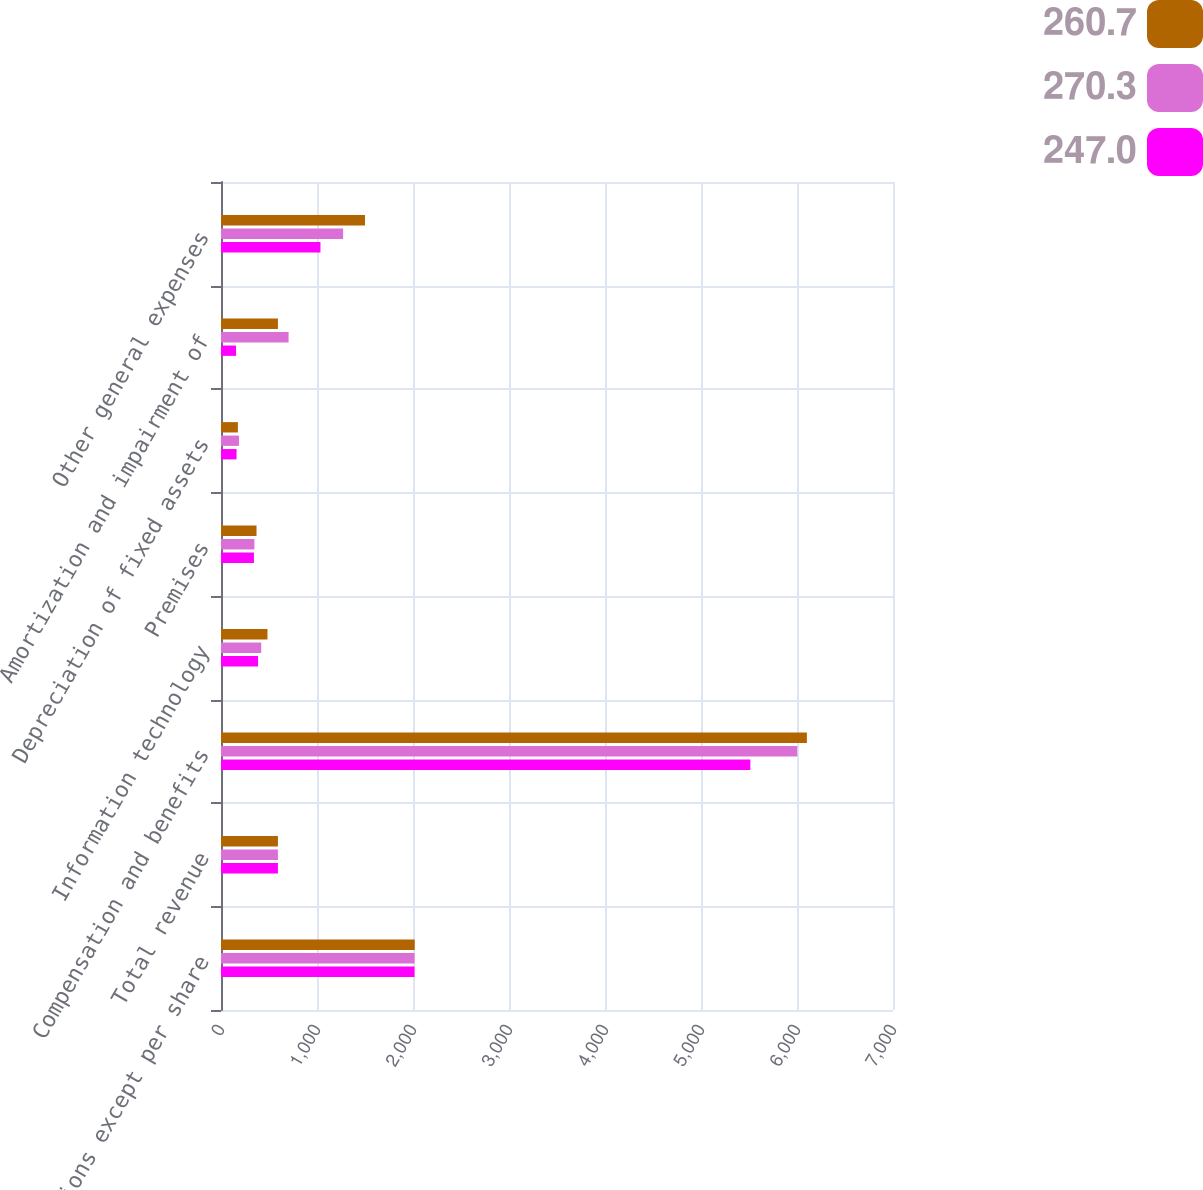Convert chart. <chart><loc_0><loc_0><loc_500><loc_500><stacked_bar_chart><ecel><fcel>(millions except per share<fcel>Total revenue<fcel>Compensation and benefits<fcel>Information technology<fcel>Premises<fcel>Depreciation of fixed assets<fcel>Amortization and impairment of<fcel>Other general expenses<nl><fcel>260.7<fcel>2018<fcel>593<fcel>6103<fcel>484<fcel>370<fcel>176<fcel>593<fcel>1500<nl><fcel>270.3<fcel>2017<fcel>593<fcel>6003<fcel>419<fcel>348<fcel>187<fcel>704<fcel>1272<nl><fcel>247<fcel>2016<fcel>593<fcel>5514<fcel>386<fcel>343<fcel>162<fcel>157<fcel>1036<nl></chart> 